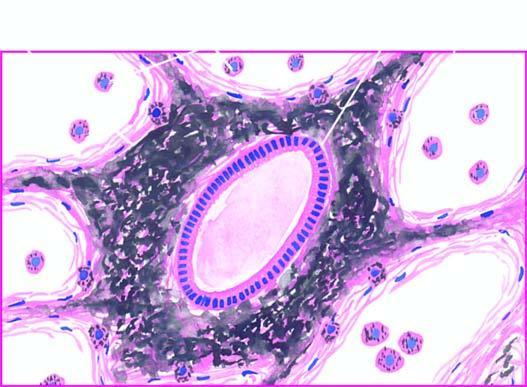where is presence of abundant coarse black carbon pigment?
Answer the question using a single word or phrase. In the septal walls and around the bronchiole 